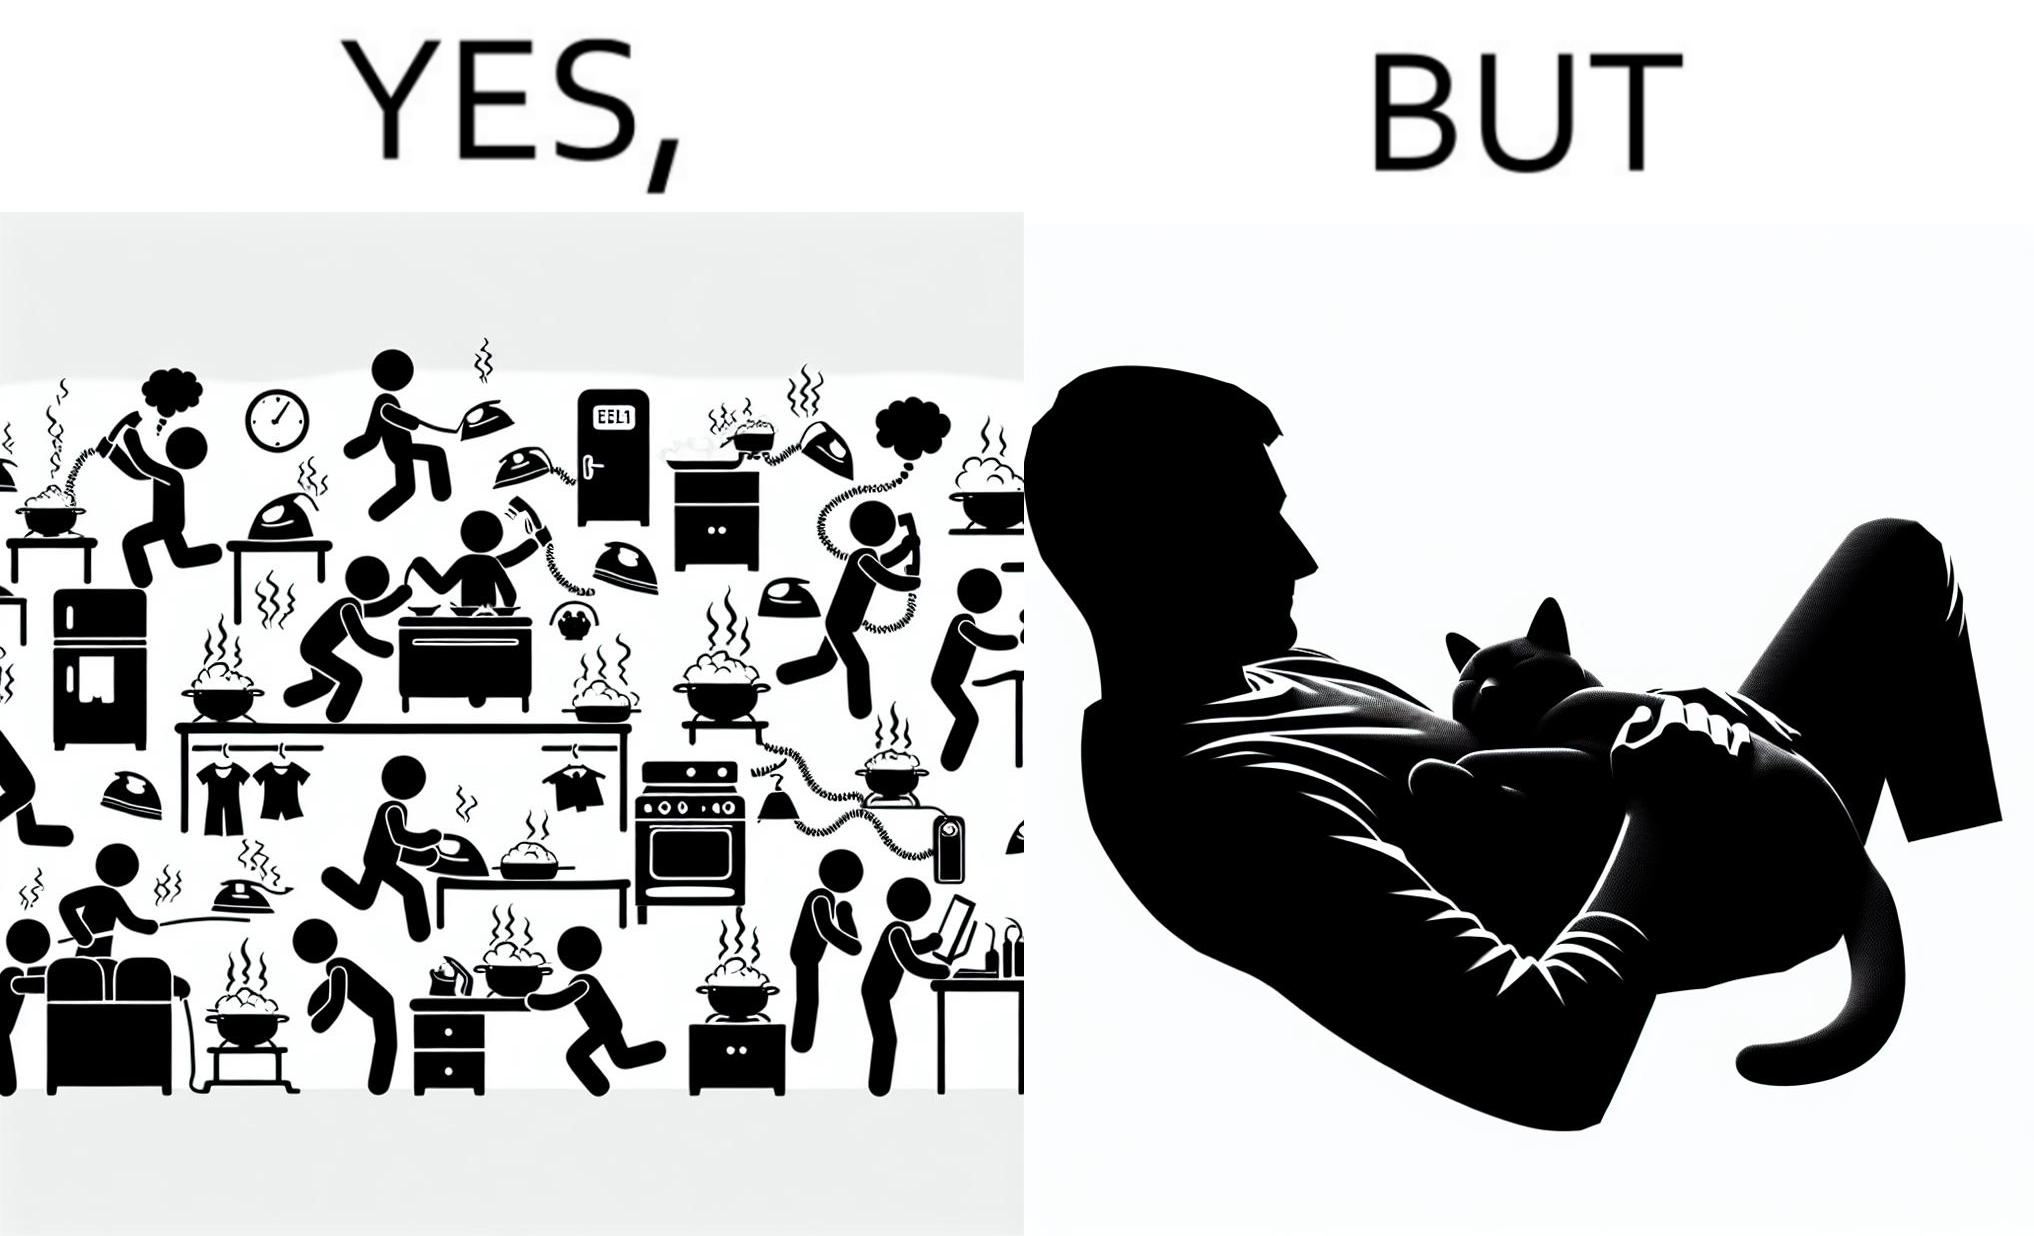Compare the left and right sides of this image. In the left part of the image: Image depicts chaos in a household with overflowing pots, ringing phone, door bell going off, and the iron burning clothes In the right part of the image: a cat sleeping on the lap of a person 